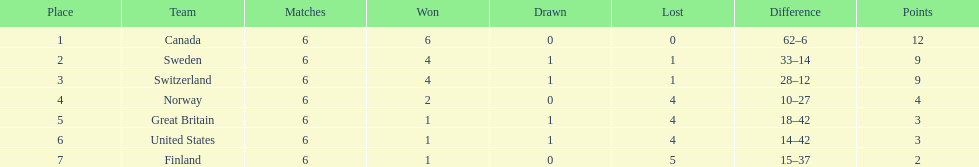Which team won more matches, finland or norway? Norway. 